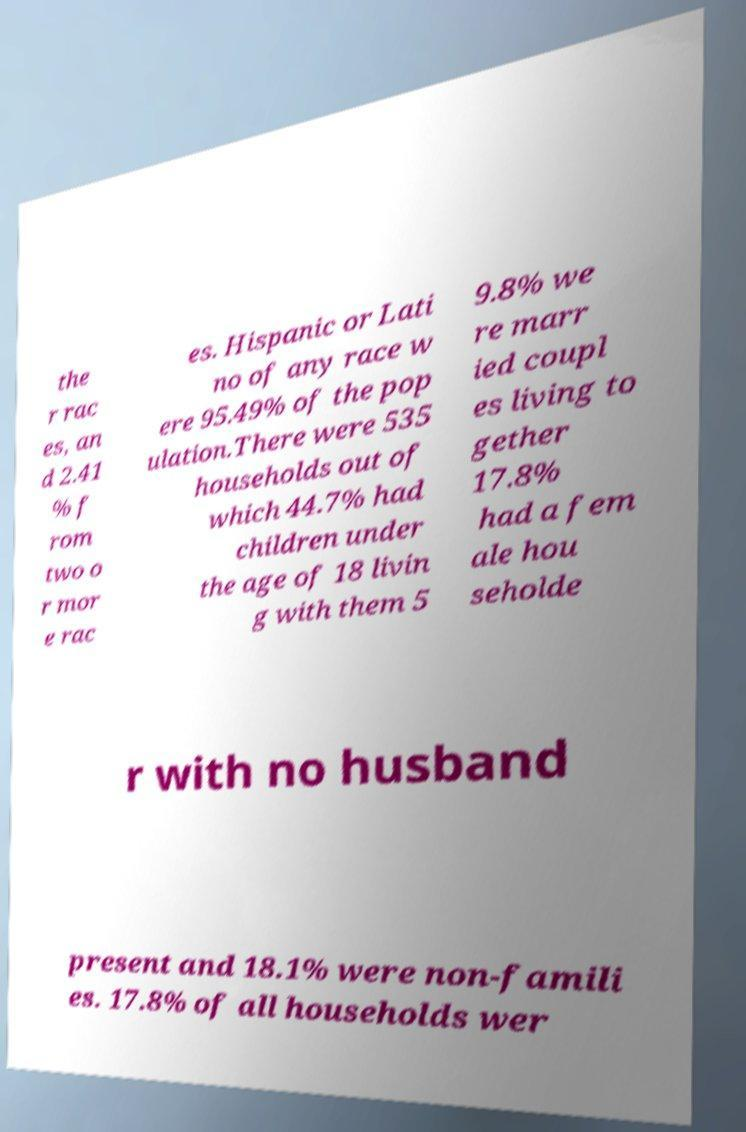There's text embedded in this image that I need extracted. Can you transcribe it verbatim? the r rac es, an d 2.41 % f rom two o r mor e rac es. Hispanic or Lati no of any race w ere 95.49% of the pop ulation.There were 535 households out of which 44.7% had children under the age of 18 livin g with them 5 9.8% we re marr ied coupl es living to gether 17.8% had a fem ale hou seholde r with no husband present and 18.1% were non-famili es. 17.8% of all households wer 